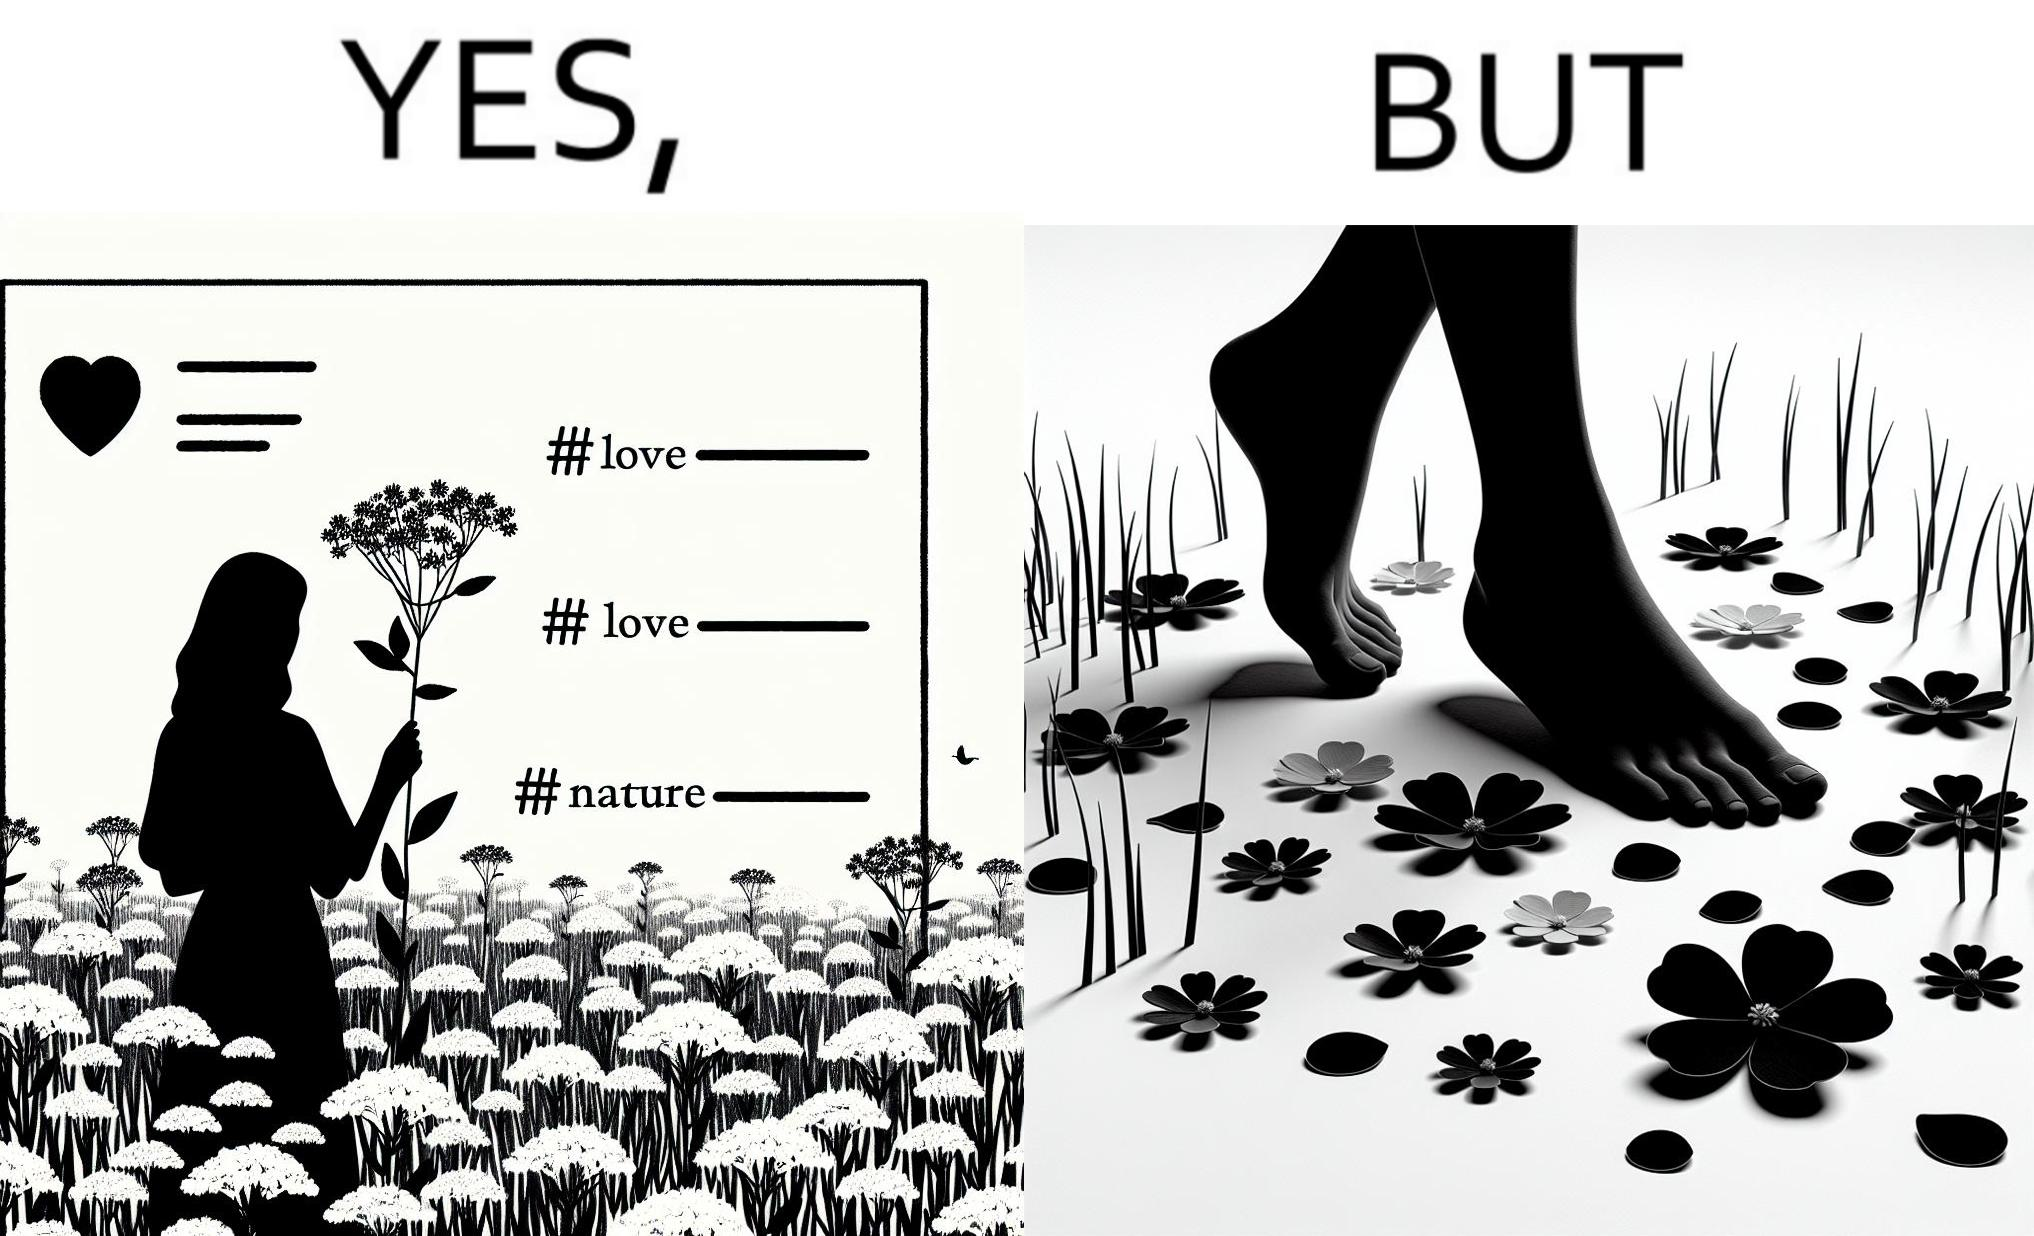What is the satirical meaning behind this image? The image is ironical, as the social ,edia post shows the appreciation of nature, while an image of the feet on the ground stepping on the flower petals shows an unintentional disrespect of nature. 